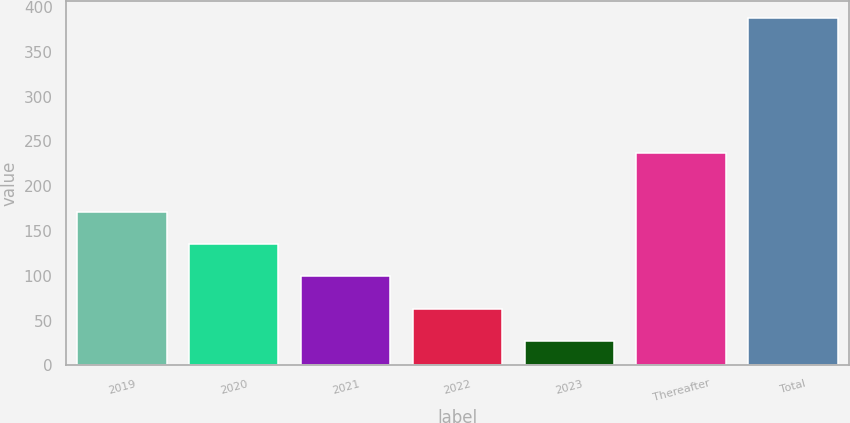<chart> <loc_0><loc_0><loc_500><loc_500><bar_chart><fcel>2019<fcel>2020<fcel>2021<fcel>2022<fcel>2023<fcel>Thereafter<fcel>Total<nl><fcel>171.3<fcel>135.3<fcel>99.3<fcel>63.3<fcel>27.3<fcel>236.6<fcel>387.3<nl></chart> 